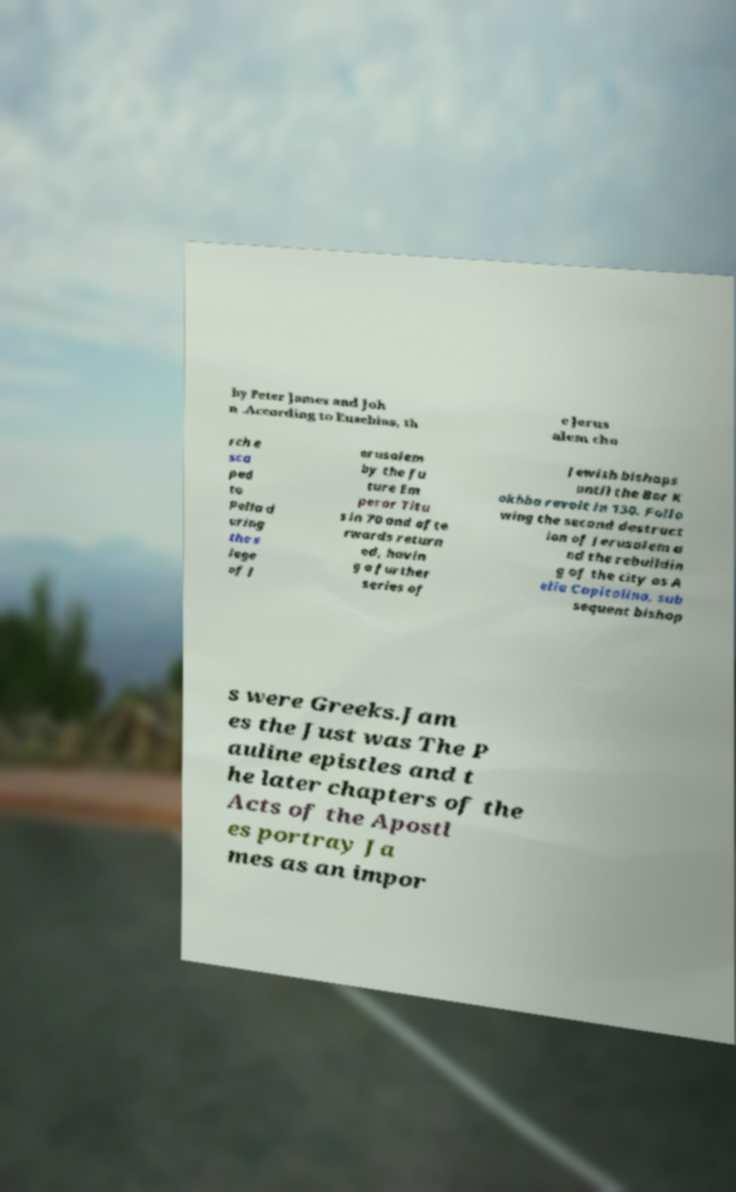Please identify and transcribe the text found in this image. by Peter James and Joh n .According to Eusebius, th e Jerus alem chu rch e sca ped to Pella d uring the s iege of J erusalem by the fu ture Em peror Titu s in 70 and afte rwards return ed, havin g a further series of Jewish bishops until the Bar K okhba revolt in 130. Follo wing the second destruct ion of Jerusalem a nd the rebuildin g of the city as A elia Capitolina, sub sequent bishop s were Greeks.Jam es the Just was The P auline epistles and t he later chapters of the Acts of the Apostl es portray Ja mes as an impor 